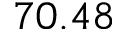<formula> <loc_0><loc_0><loc_500><loc_500>7 0 . 4 8</formula> 